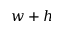<formula> <loc_0><loc_0><loc_500><loc_500>w + h</formula> 